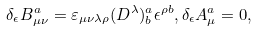<formula> <loc_0><loc_0><loc_500><loc_500>\delta _ { \epsilon } B _ { \mu \nu } ^ { a } = \varepsilon _ { \mu \nu \lambda \rho } ( D ^ { \lambda } ) _ { b } ^ { a } \epsilon ^ { \rho b } , \delta _ { \epsilon } A _ { \mu } ^ { a } = 0 ,</formula> 